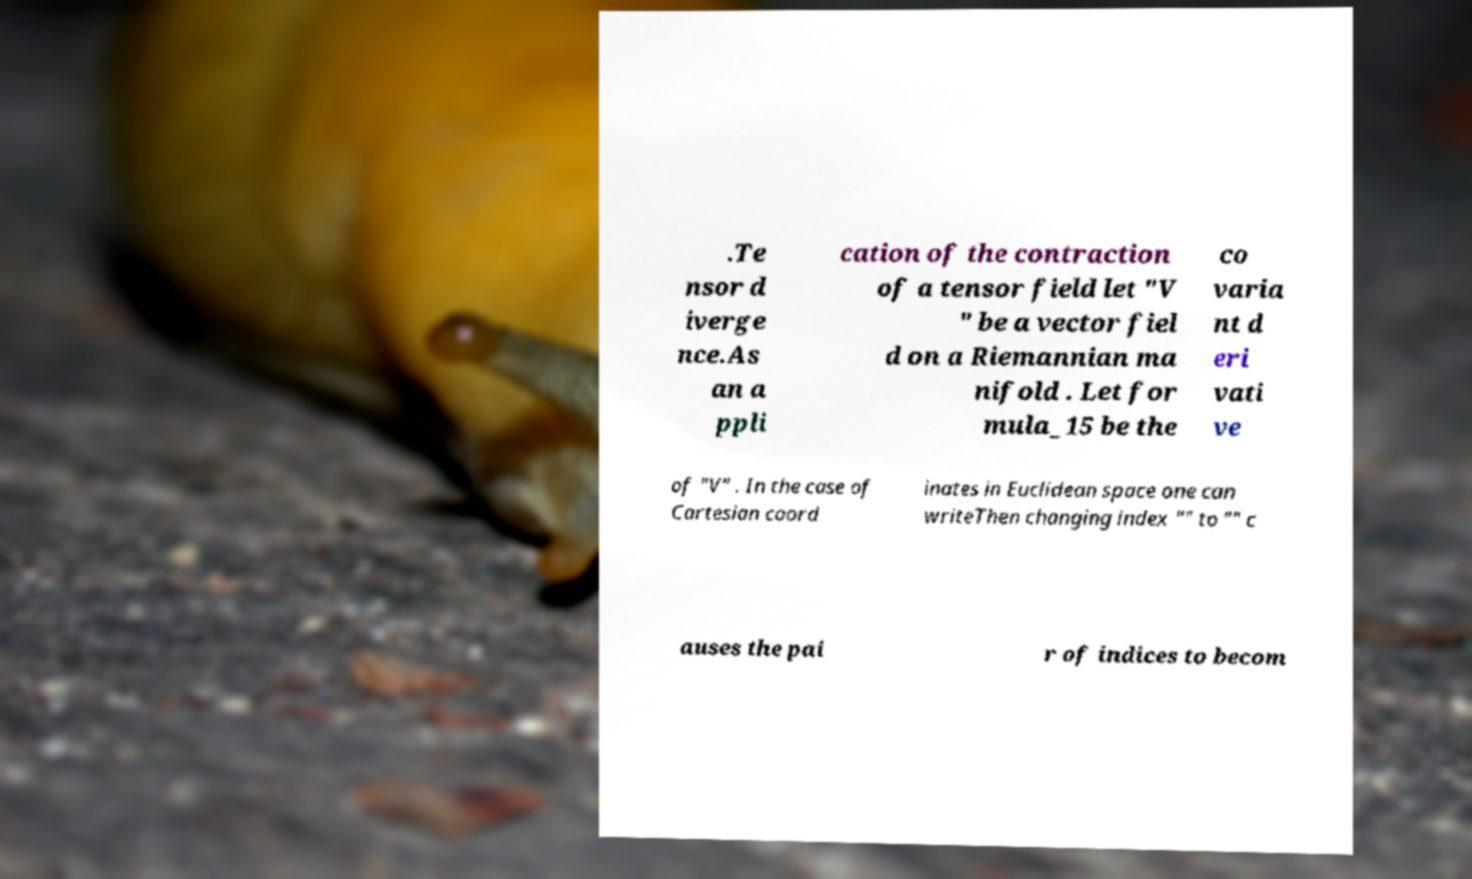Please identify and transcribe the text found in this image. .Te nsor d iverge nce.As an a ppli cation of the contraction of a tensor field let "V " be a vector fiel d on a Riemannian ma nifold . Let for mula_15 be the co varia nt d eri vati ve of "V" . In the case of Cartesian coord inates in Euclidean space one can writeThen changing index "" to "" c auses the pai r of indices to becom 